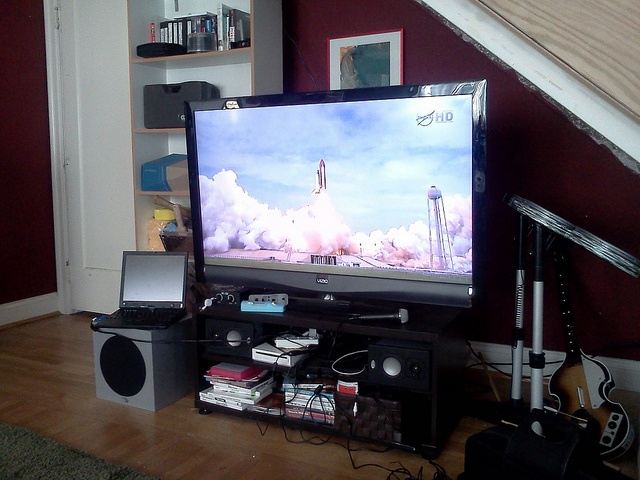Describe the objects in this image and their specific colors. I can see tv in black, lavender, and gray tones, laptop in black, gray, and darkgray tones, book in black, gray, darkgray, and lightgray tones, book in black, gray, darkgray, and lightgray tones, and keyboard in black and gray tones in this image. 